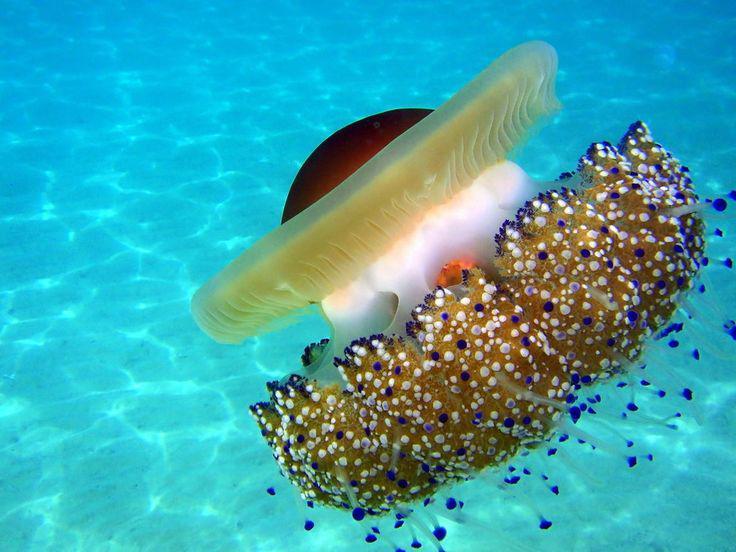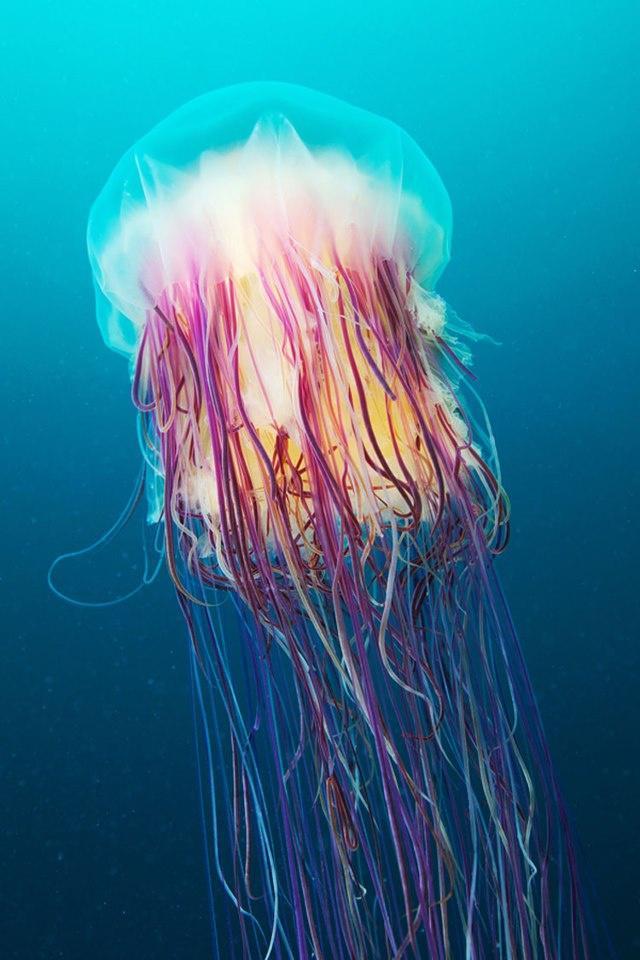The first image is the image on the left, the second image is the image on the right. Examine the images to the left and right. Is the description "The jellyfish in the image on the right is pink." accurate? Answer yes or no. Yes. The first image is the image on the left, the second image is the image on the right. For the images displayed, is the sentence "An image features one large anemone with a dome-like projection on one end and the other covered in small colored dots." factually correct? Answer yes or no. Yes. 